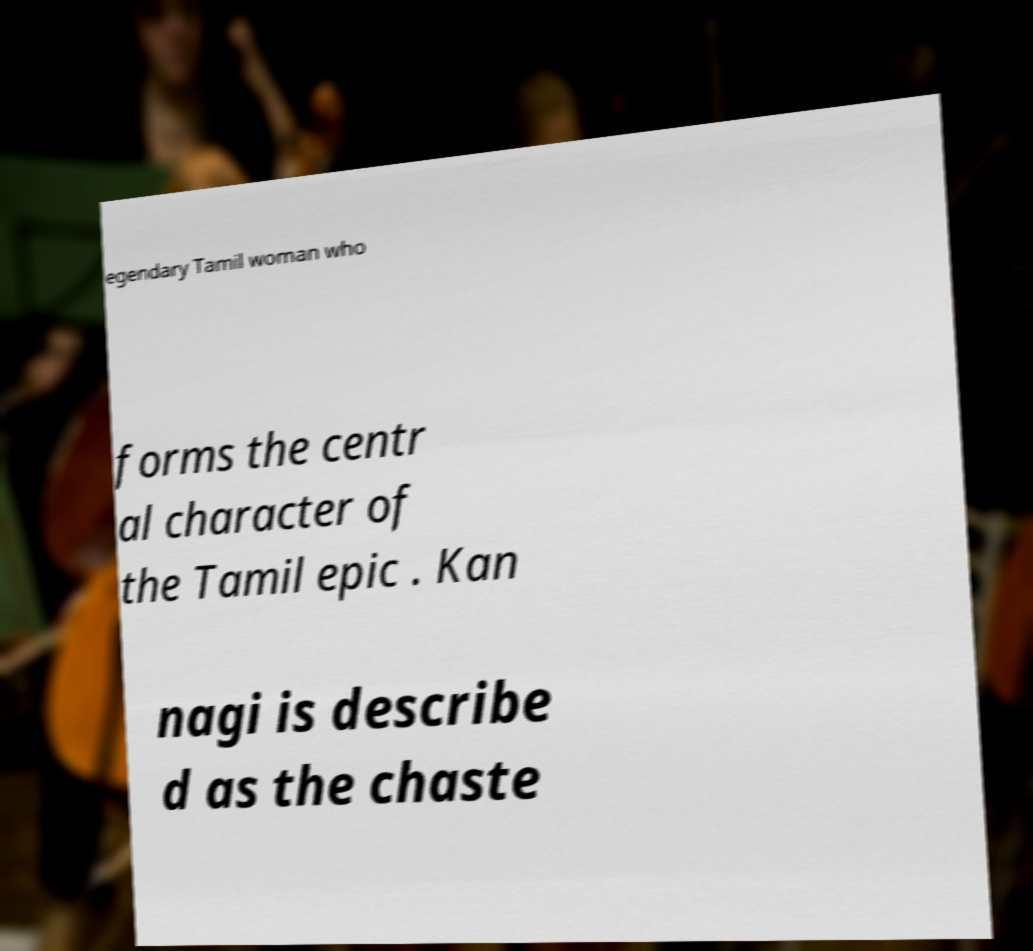Please identify and transcribe the text found in this image. egendary Tamil woman who forms the centr al character of the Tamil epic . Kan nagi is describe d as the chaste 